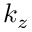Convert formula to latex. <formula><loc_0><loc_0><loc_500><loc_500>k _ { z }</formula> 